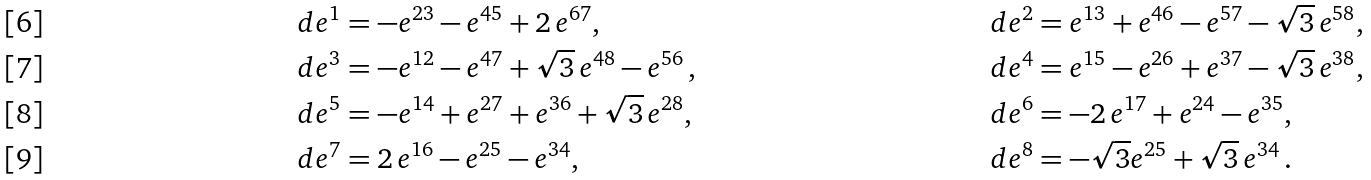<formula> <loc_0><loc_0><loc_500><loc_500>d e ^ { 1 } & = - e ^ { 2 3 } - e ^ { 4 5 } + 2 \, e ^ { 6 7 } , & d e ^ { 2 } & = e ^ { 1 3 } + e ^ { 4 6 } - e ^ { 5 7 } - { \sqrt { 3 } } \, e ^ { 5 8 } , \\ d e ^ { 3 } & = - e ^ { 1 2 } - e ^ { 4 7 } + { \sqrt { 3 } } \, e ^ { 4 8 } - e ^ { 5 6 } \, , & d e ^ { 4 } & = e ^ { 1 5 } - e ^ { 2 6 } + e ^ { 3 7 } - { \sqrt { 3 } } \, e ^ { 3 8 } , & \\ d e ^ { 5 } & = - e ^ { 1 4 } + e ^ { 2 7 } + e ^ { 3 6 } + { \sqrt { 3 } } \, e ^ { 2 8 } , & d e ^ { 6 } & = - 2 \, e ^ { 1 7 } + e ^ { 2 4 } - e ^ { 3 5 } , & \\ d e ^ { 7 } & = 2 \, e ^ { 1 6 } - e ^ { 2 5 } - e ^ { 3 4 } , & d e ^ { 8 } & = - \sqrt { 3 } e ^ { 2 5 } + \sqrt { 3 } \, e ^ { 3 4 } \, .</formula> 